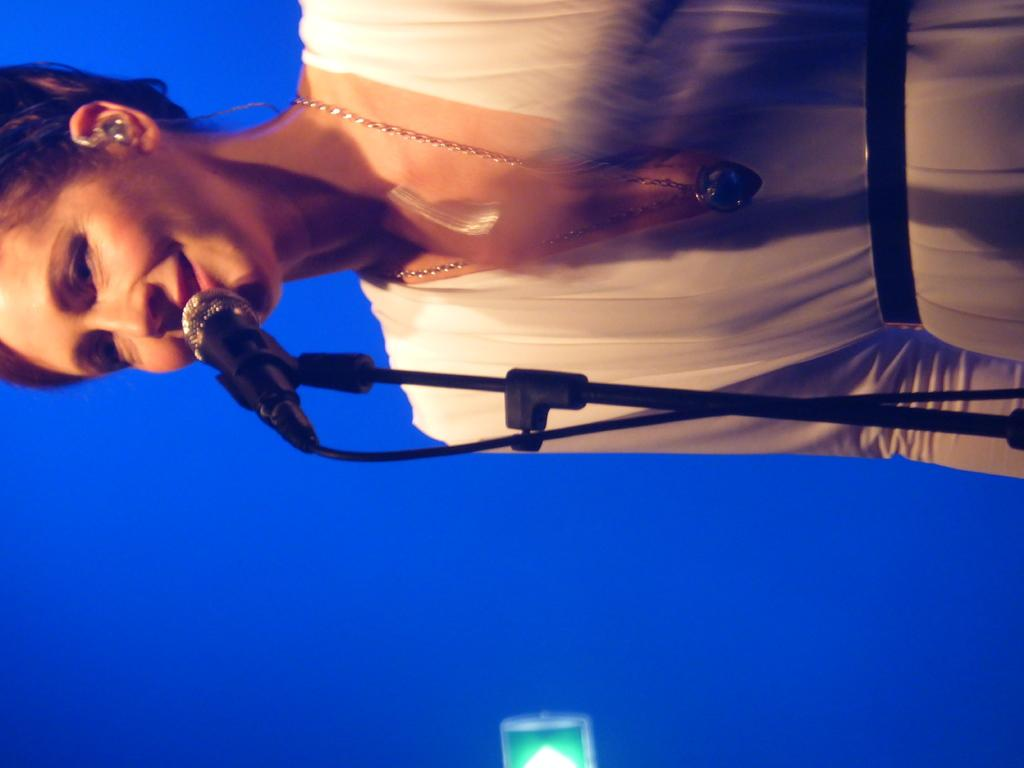What is the main subject of the image? There is a person in the image. What color is the background of the image? The background of the image is blue. What object is in front of the person? There is a mic in front of the person. Can you tell me what month is depicted on the calendar in the image? There is no calendar present in the image. What type of mountain range can be seen in the background of the image? There is no mountain range visible in the image; the background is blue. What type of ship is docked near the person in the image? There is no ship present in the image. 